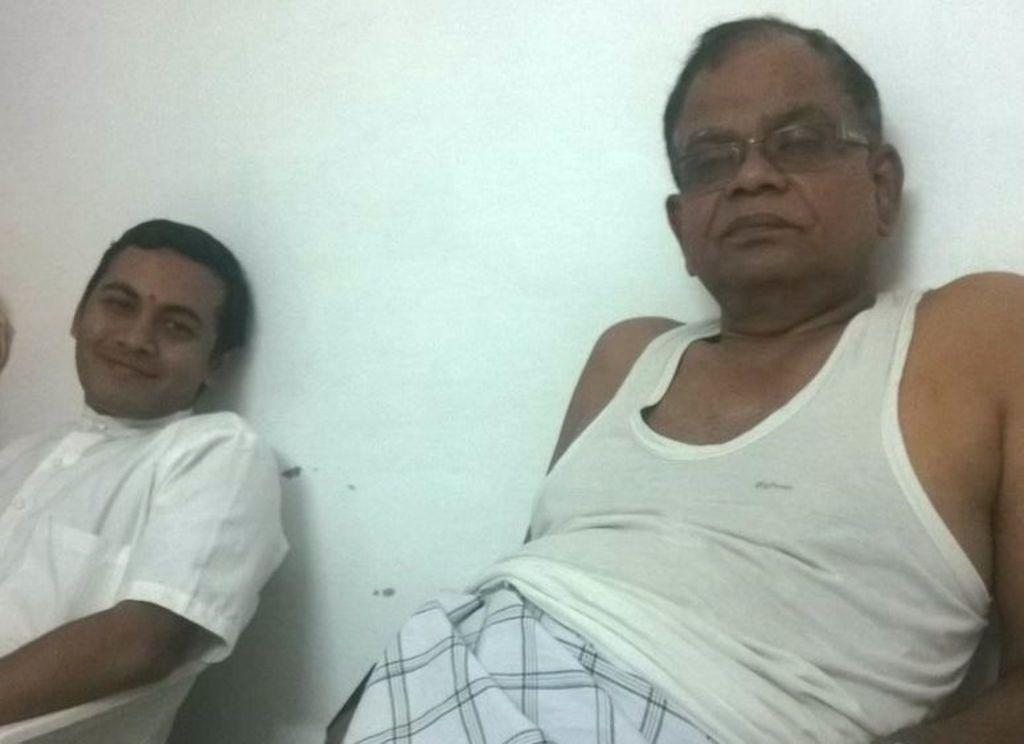How many people are present in the image? There are two persons sitting in the image. What can be seen in the background of the image? There is a wall in the background of the image. Can you describe the person on the left side of the image? The person on the left side of the image is smiling and watching. What type of bears can be seen playing with ants in the image? There are no bears or ants present in the image; it features two people sitting and a wall in the background. The image does not depict any bears or ants, so it is not possible to determine if they are playing with ants. 